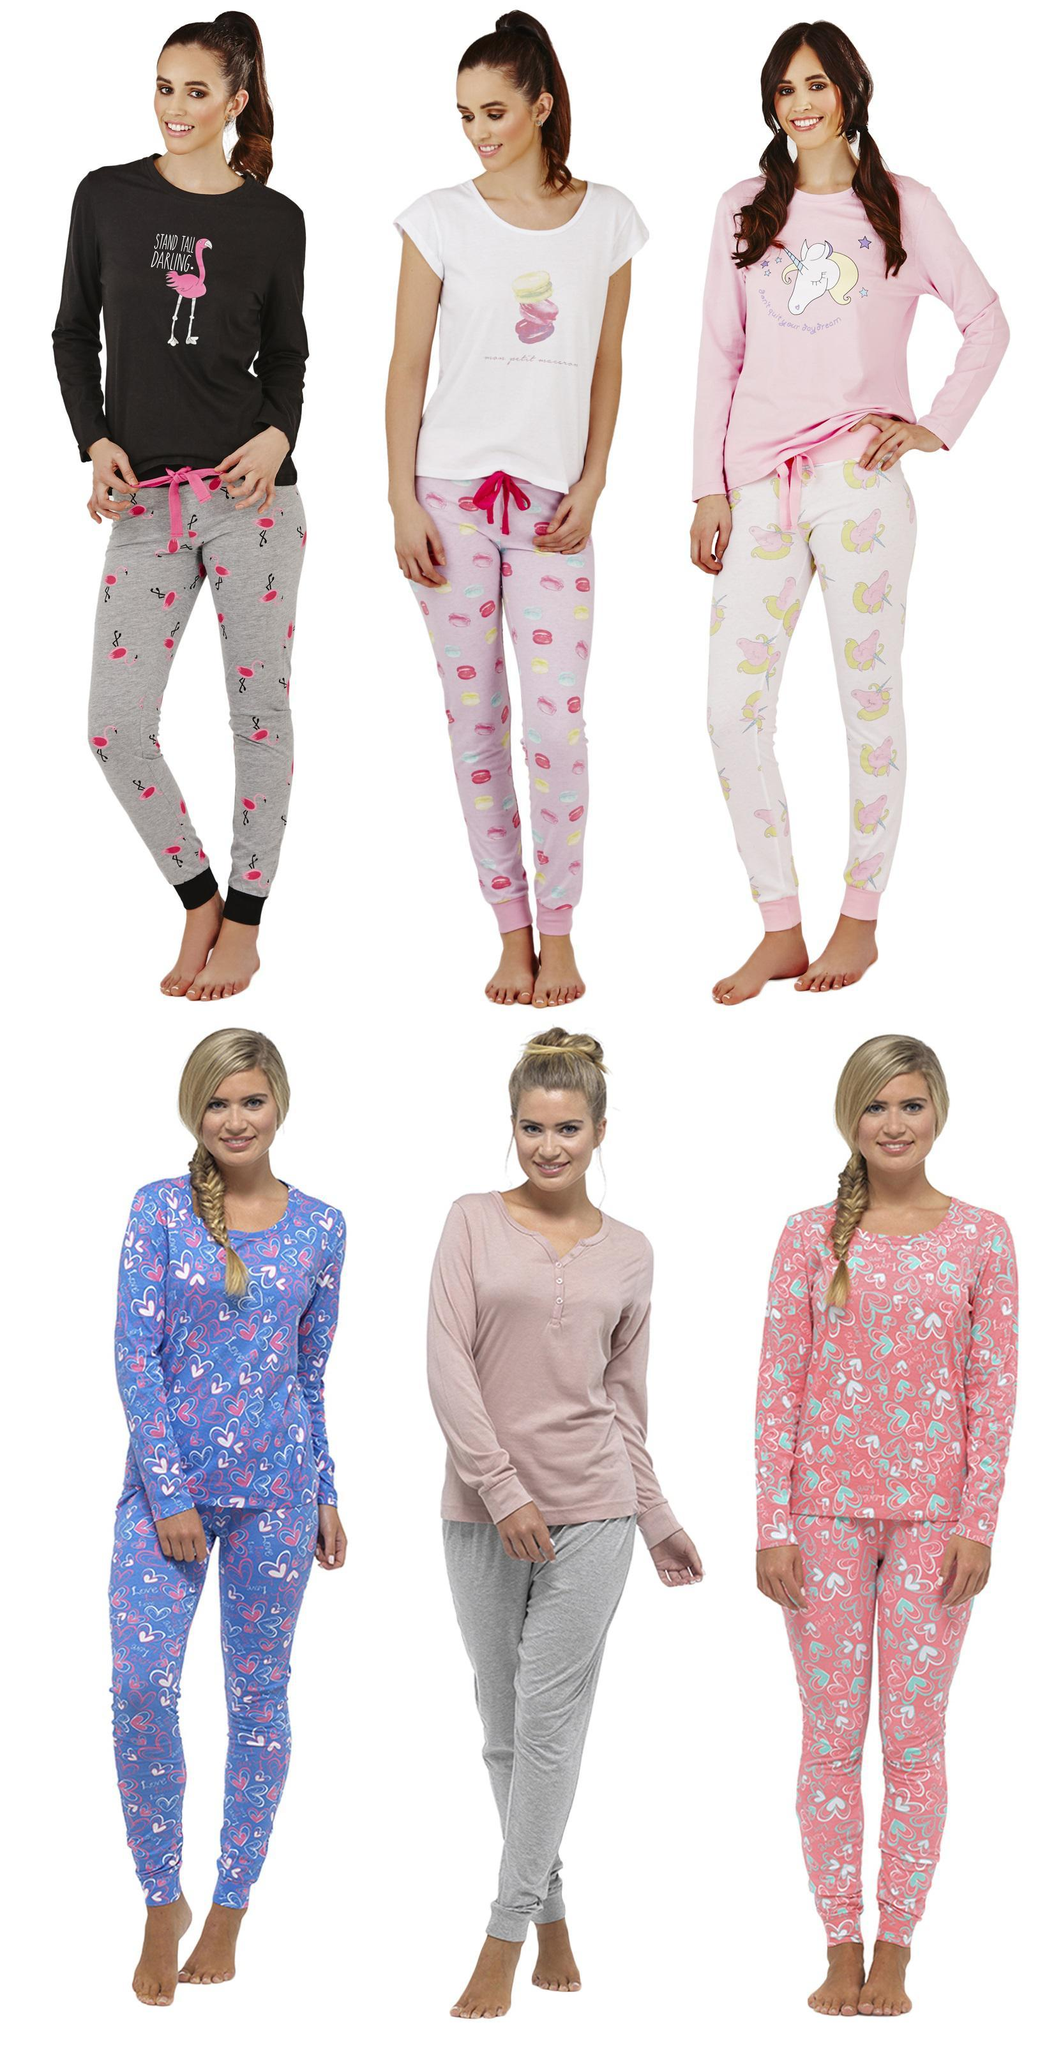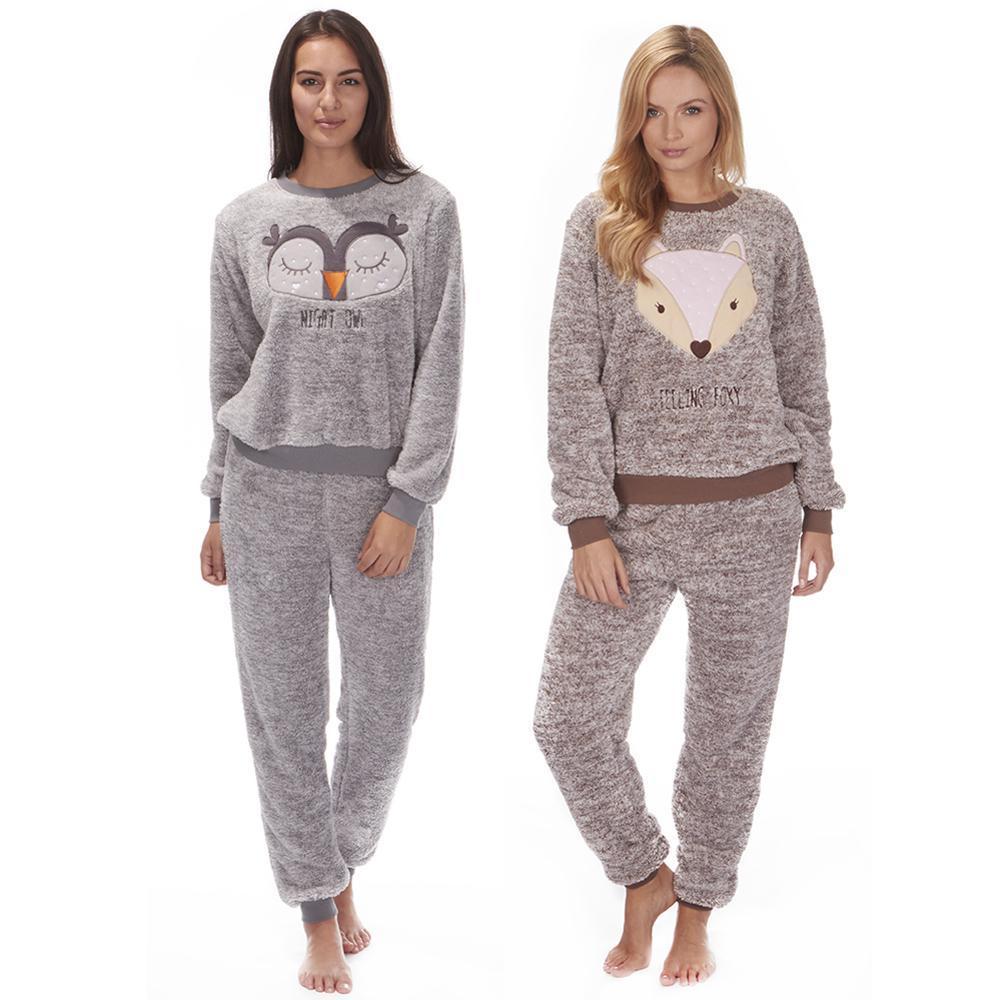The first image is the image on the left, the second image is the image on the right. For the images displayed, is the sentence "Women are wearing shirts with cartoon animals sleeping on them in one of the images." factually correct? Answer yes or no. Yes. The first image is the image on the left, the second image is the image on the right. Evaluate the accuracy of this statement regarding the images: "More than one pajama set has a depiction of an animal on the top.". Is it true? Answer yes or no. Yes. 